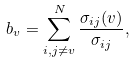<formula> <loc_0><loc_0><loc_500><loc_500>b _ { v } = \sum _ { i , j \neq v } ^ { N } \frac { \sigma _ { i j } ( v ) } { \sigma _ { i j } } ,</formula> 